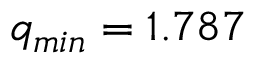<formula> <loc_0><loc_0><loc_500><loc_500>q _ { \min } = 1 . 7 8 7</formula> 